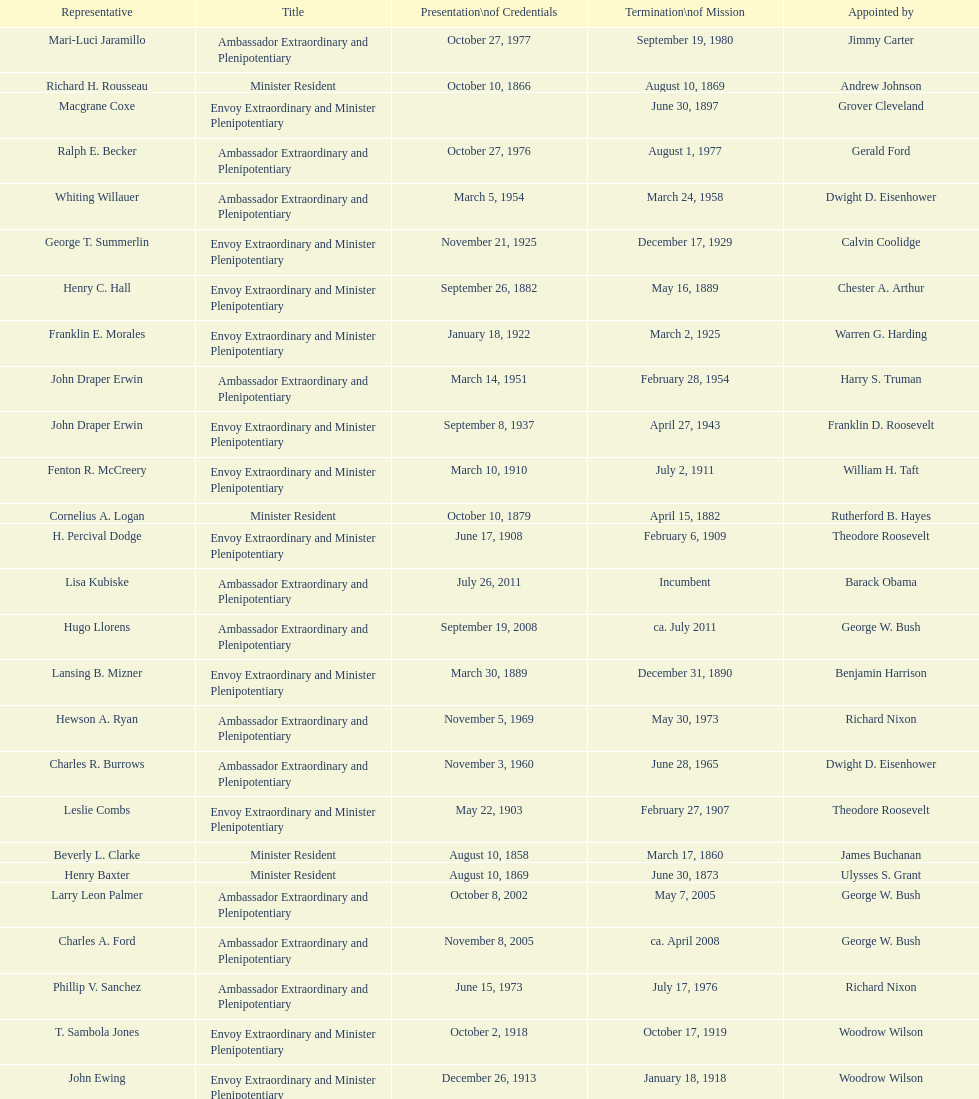Does solon borland hold a representative position? Yes. 